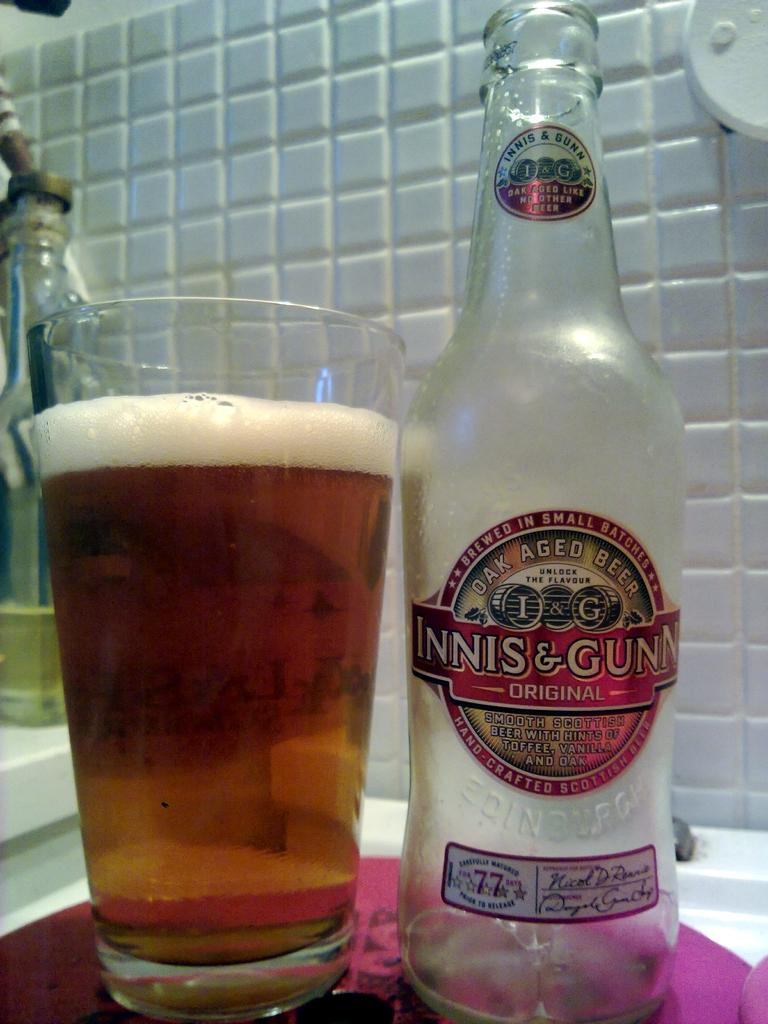What type of container is visible in the image? There is a glass bottle and a glass of wine in the image. Where are the glass bottle and the glass of wine located? Both the glass bottle and the glass of wine are placed on a table. What can be inferred about the background of the image? The background of the image is white in color. How many people are in the wilderness in the image? There is no wilderness or people present in the image; it features a glass bottle, a glass of wine, and a table. What type of container is used for preserving food in the image? There is no container for preserving food present in the image; it only features a glass bottle and a glass of wine. 